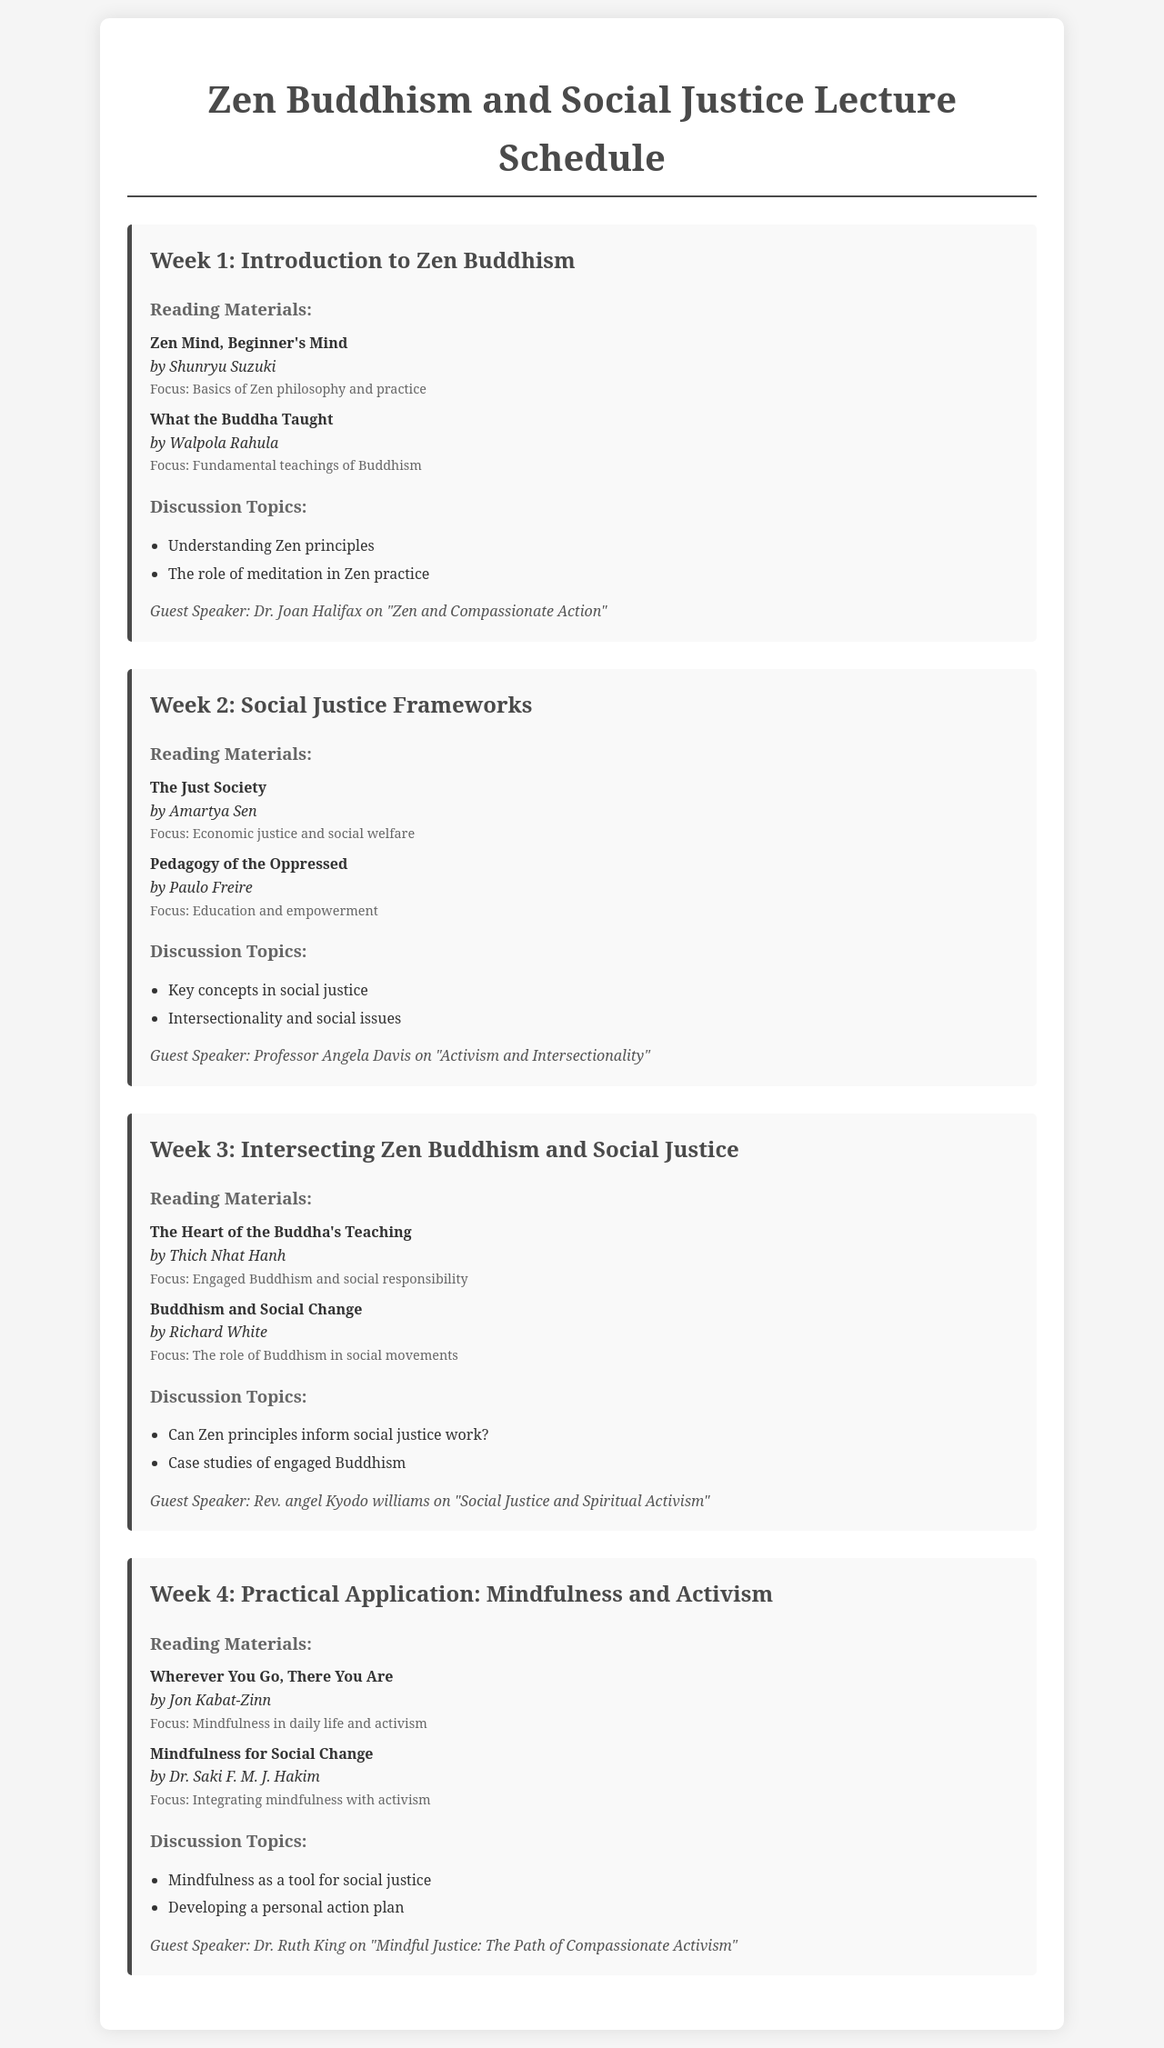What is the title of the first reading material for Week 1? The title of the first reading material for Week 1 is listed in the reading section for that week.
Answer: Zen Mind, Beginner's Mind Who is the guest speaker for Week 2? The guest speaker's name is mentioned in the second week's section of the document.
Answer: Professor Angela Davis What is the focus of Thich Nhat Hanh's book? The focus of the book is detailed under the reading materials for Week 3.
Answer: Engaged Buddhism and social responsibility How many weeks are covered in the schedule? The number of weeks is determined by counting the week sections in the document.
Answer: 4 What is the discussion topic for Week 4? One of the discussion topics is listed in the discussion topics section for the specified week.
Answer: Mindfulness as a tool for social justice Which author wrote "Pedagogy of the Oppressed"? The author's name is provided with the reading material titles in Week 2.
Answer: Paulo Freire What is the main focus of the reading titled "Mindfulness for Social Change"? The main focus is found in the reading materials' focus descriptions in Week 4.
Answer: Integrating mindfulness with activism Who is the guest speaker for Week 3? The guest speaker's name is provided in the respective week section.
Answer: Rev. angel Kyodo williams 